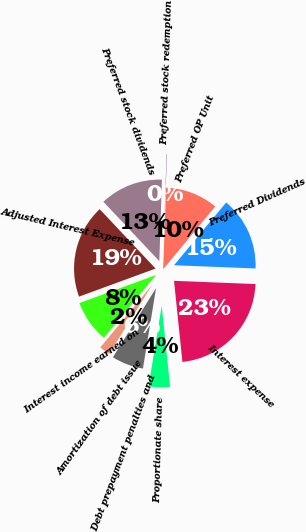Convert chart to OTSL. <chart><loc_0><loc_0><loc_500><loc_500><pie_chart><fcel>Interest expense<fcel>Proportionate share<fcel>Debt prepayment penalties and<fcel>Amortization of debt issue<fcel>Interest income earned on<fcel>Adjusted Interest Expense<fcel>Preferred stock dividends<fcel>Preferred stock redemption<fcel>Preferred OP Unit<fcel>Preferred Dividends<nl><fcel>22.72%<fcel>4.22%<fcel>6.3%<fcel>2.15%<fcel>8.38%<fcel>18.57%<fcel>12.53%<fcel>0.07%<fcel>10.45%<fcel>14.6%<nl></chart> 